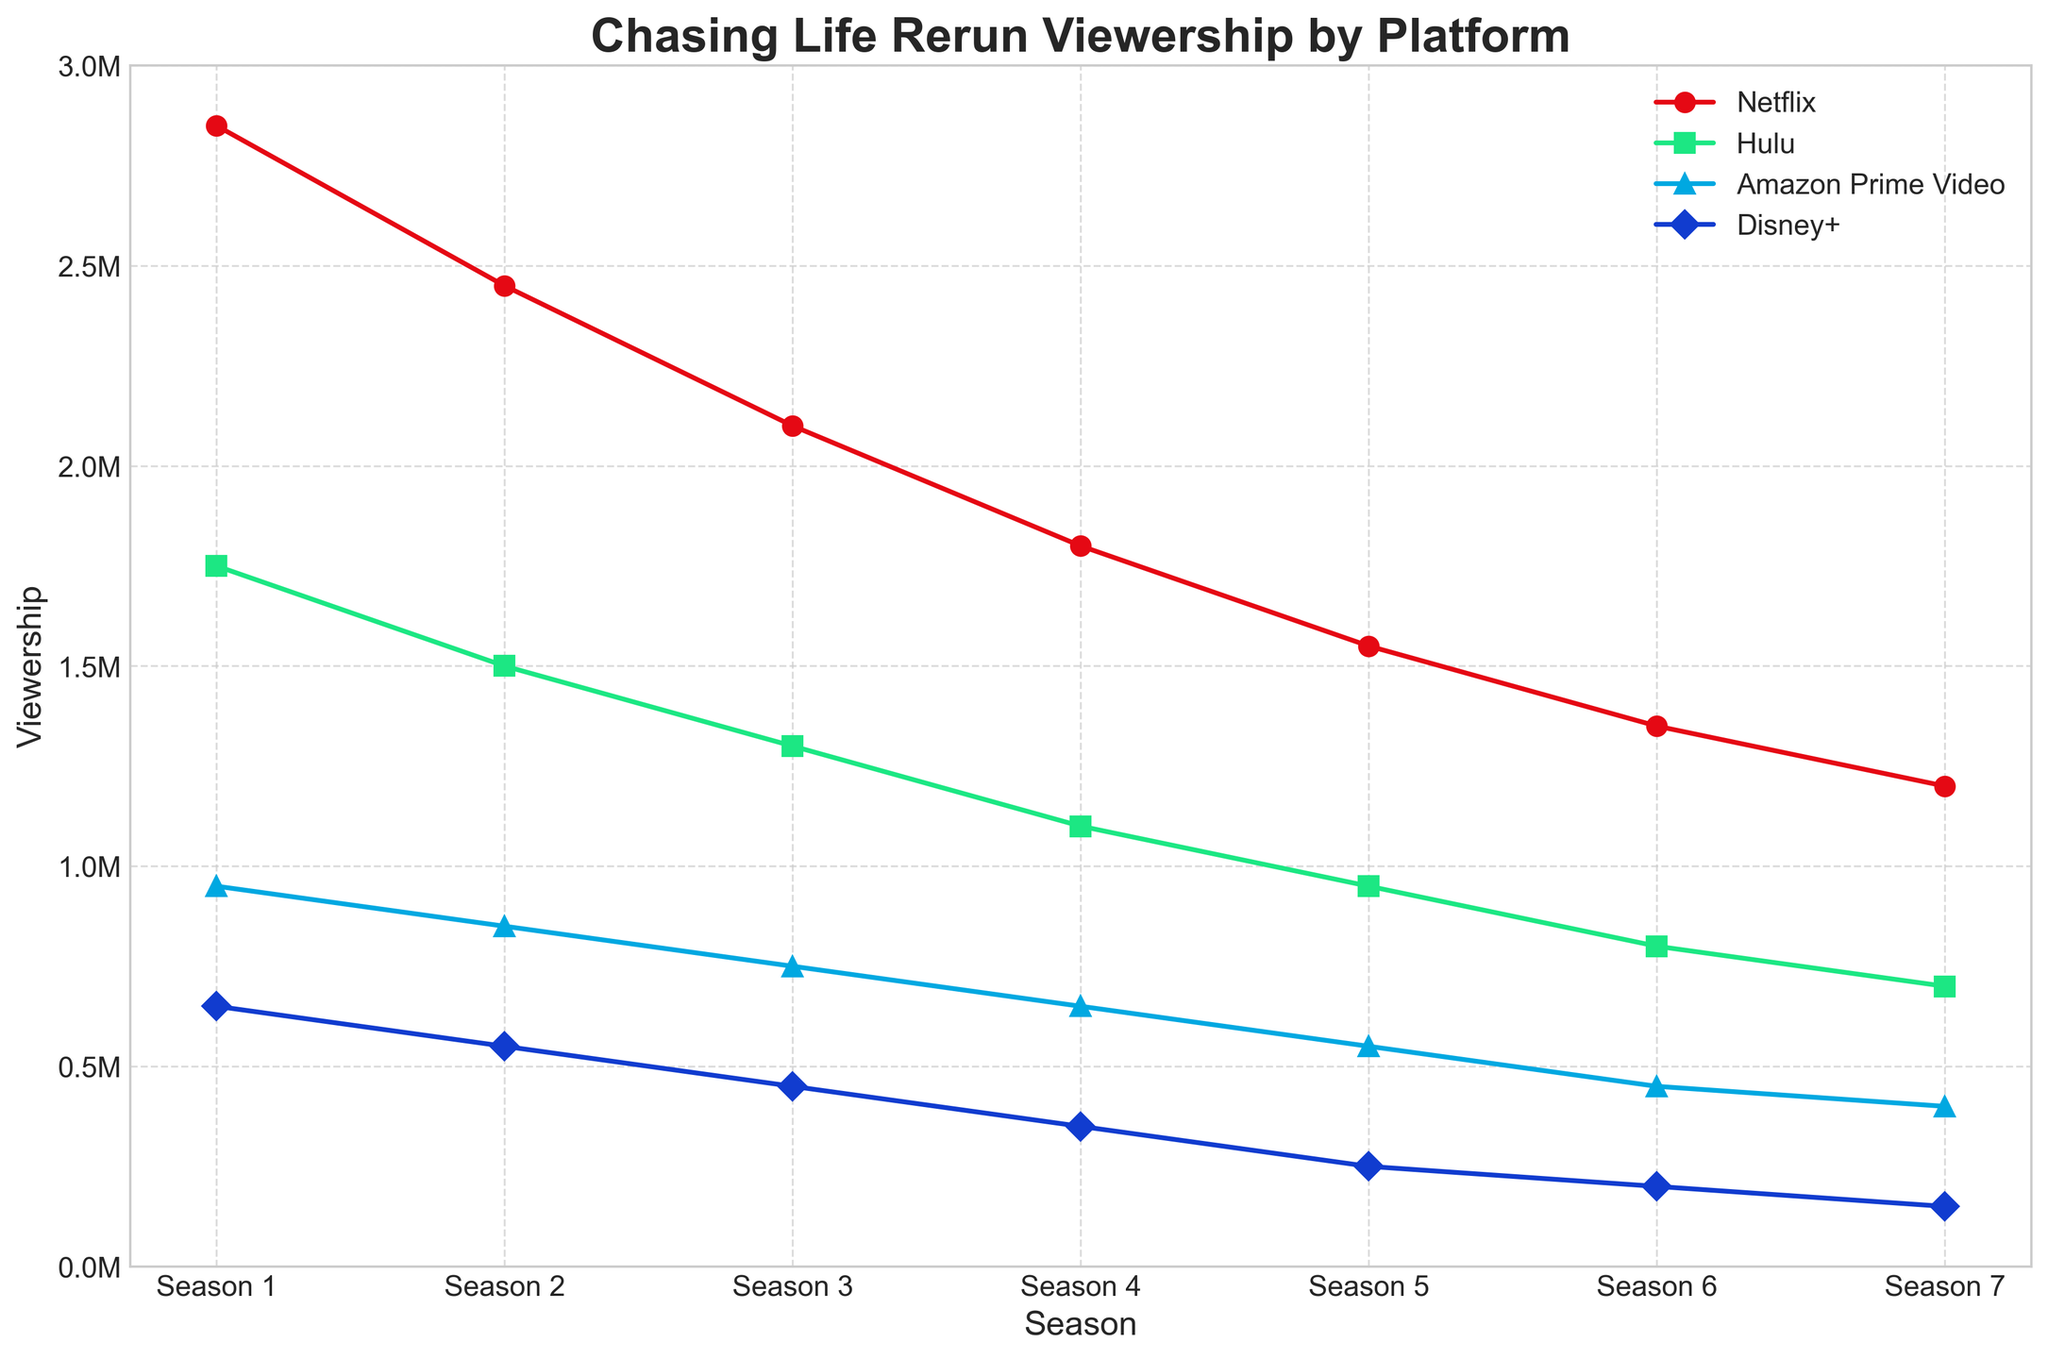Which season had the highest viewership across all platforms combined? To find the season with the highest combined viewership, we add the viewership numbers for each platform per season and compare them. Season 1: 2850000 (Netflix) + 1750000 (Hulu) + 950000 (Amazon Prime Video) + 650000 (Disney+) = 6200000. Similarly, calculate for other seasons and compare. Season 1 has the highest combined viewership.
Answer: Season 1 Which platform had the least viewership for Season 4? To determine this, look at the data for Season 4 and identify the platform with the lowest viewership numbers. The values for Season 4 are: Netflix: 1800000, Hulu: 1100000, Amazon Prime Video: 650000, Disney+: 350000. Disney+ has the lowest viewership.
Answer: Disney+ How did Netflix viewership change from Season 1 to Season 4? To find the change in Netflix viewership from Season 1 to Season 4, subtract the viewership of Season 4 from that of Season 1. Season 1: 2850000, Season 4: 1800000. Change = 2850000 - 1800000 = 1050000.
Answer: Decreased by 1050000 Which season had the smallest decrease in Hulu viewership compared to the previous season? Calculate the decrease in Hulu viewership between each consecutive season: Season 1 to 2: 1750000 - 1500000 = 250000, Season 2 to 3: 1500000 - 1300000 = 200000, Season 3 to 4: 1300000 - 1100000 = 200000, Season 4 to 5: 1100000 - 950000 = 150000, Season 5 to 6: 950000 - 800000 = 150000, Season 6 to 7: 800000 - 700000 = 100000. Season 6 to 7 had the smallest decrease.
Answer: Season 7 Which platform shows the most consistent decline in viewership across the seasons? To identify the platform with the most consistent decline, check if there's a steady decrease in viewership for all seasons. Looking at the data: Netflix: 2850000, 2450000, 2100000, 1800000, 1550000, 1350000, 1200000. Hulu: 1750000, 1500000, 1300000, 1100000, 950000, 800000, 700000. Amazon Prime Video: 950000, 850000, 750000, 650000, 550000, 450000, 400000. Disney+: 650000, 550000, 450000, 350000, 250000, 200000, 150000. All platforms show a consistent decline, but Hulu shows a steady pattern without fluctuations.
Answer: Hulu By how much did the viewership of "Chasing Life" decrease on Amazon Prime Video from Season 1 to Season 7? Calculate the decrease in viewership on Amazon Prime Video from Season 1 to Season 7 by subtracting the Season 7 viewership from the Season 1 viewership: Season 1: 950000, Season 7: 400000. Decrease = 950000 - 400000 = 550000.
Answer: 550000 During which season did Disney+ viewership fall below 300,000? Look at the Disney+ viewership numbers and identify when it drops below 300000. Season 1: 650000, Season 2: 550000, Season 3: 450000, Season 4: 350000, Season 5: 250000, Season 6: 200000, Season 7: 150000. Disney+ viewership falls below 300000 in Season 5.
Answer: Season 5 Does the viewership trend for Hulu follow a linear decline across all seasons? To determine linear decline, check if the decrease per season in Hulu viewership is constant. The differences are: Season 1 to 2: 250000, Season 2 to 3: 200000, Season 3 to 4: 200000, Season 4 to 5: 150000, Season 5 to 6: 150000, Season 6 to 7: 100000. The declines are not constant, showing a generally decreasing but non-linear trend.
Answer: No 